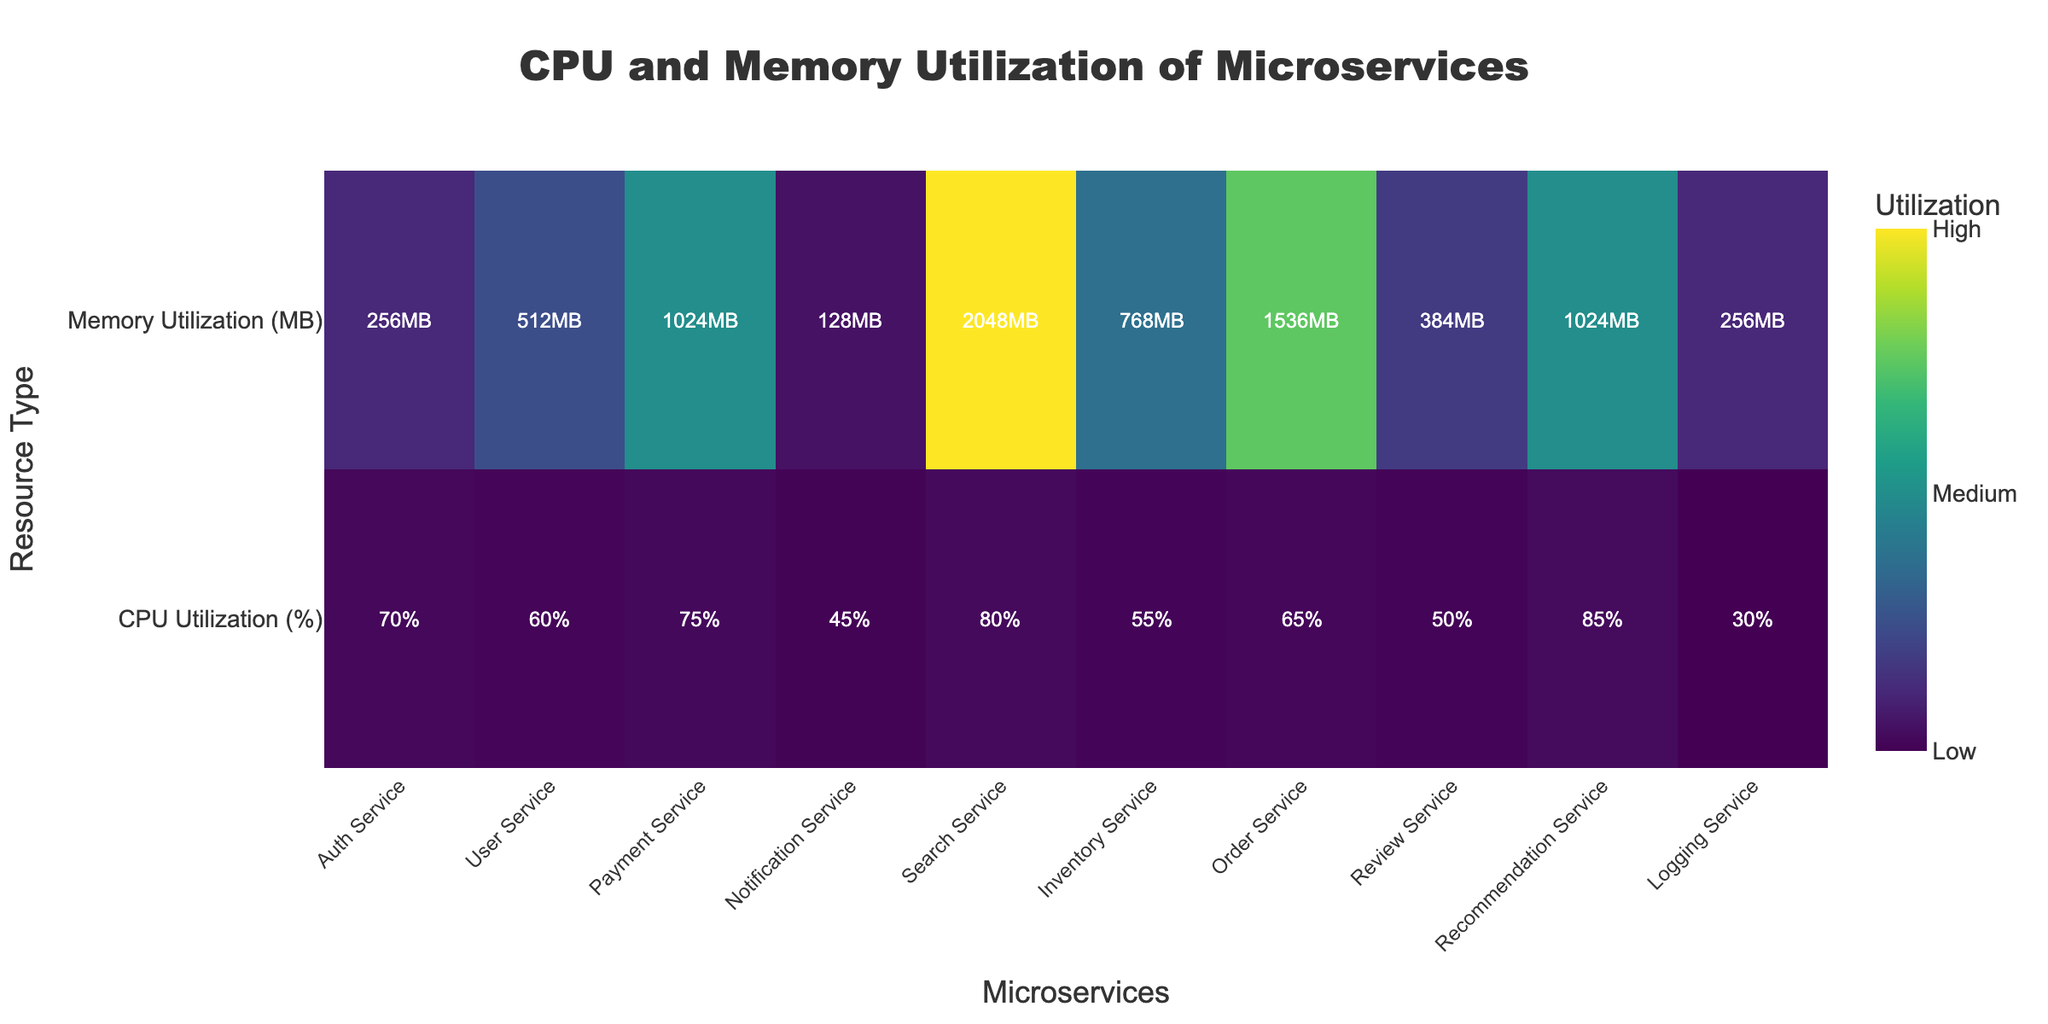What is the title of the heatmap? The title of the heatmap is displayed prominently at the top of the figure, making it easy to identify without any calculations or deep analysis.
Answer: CPU and Memory Utilization of Microservices Which microservice has the highest CPU utilization? By scanning the CPU Utilization row, the color intensity and annotated text indicate the highest value.
Answer: Recommendation Service Which microservice uses the most memory? Similarly, look at the Memory Utilization row to find the service with the highest annotated value and the most intense color.
Answer: Search Service What's the CPU utilization for the Notification Service? Locate the Notification Service along the x-axis, and find the value in the CPU Utilization row.
Answer: 45% What's the memory utilization for the User Service? Locate the User Service along the x-axis, and find the value in the Memory Utilization row.
Answer: 512MB What is the difference in CPU utilization between the Payment Service and the Logging Service? Find the CPU utilization values for both services (75% for Payment Service and 30% for Logging Service) and subtract them.
Answer: 45% What is the average CPU utilization of all microservices? Add up the CPU utilization values of all services and divide by the number of services (10).
Answer: 61% How does the memory utilization of the Order Service compare to the Inventory Service? Check the annotated memory values of both services (1536MB for Order Service and 768MB for Inventory Service) and compare them.
Answer: Order Service uses twice as much memory Which microservice has both high CPU and memory utilization? Identify the service with high values in both CPU and Memory rows; high values usually have intense colors.
Answer: Recommendation Service Is there a positive correlation between CPU and memory utilization across the microservices? Visually check if higher CPU utilization generally corresponds to higher memory utilization by observing the color intensities and annotations across both rows.
Answer: Yes 